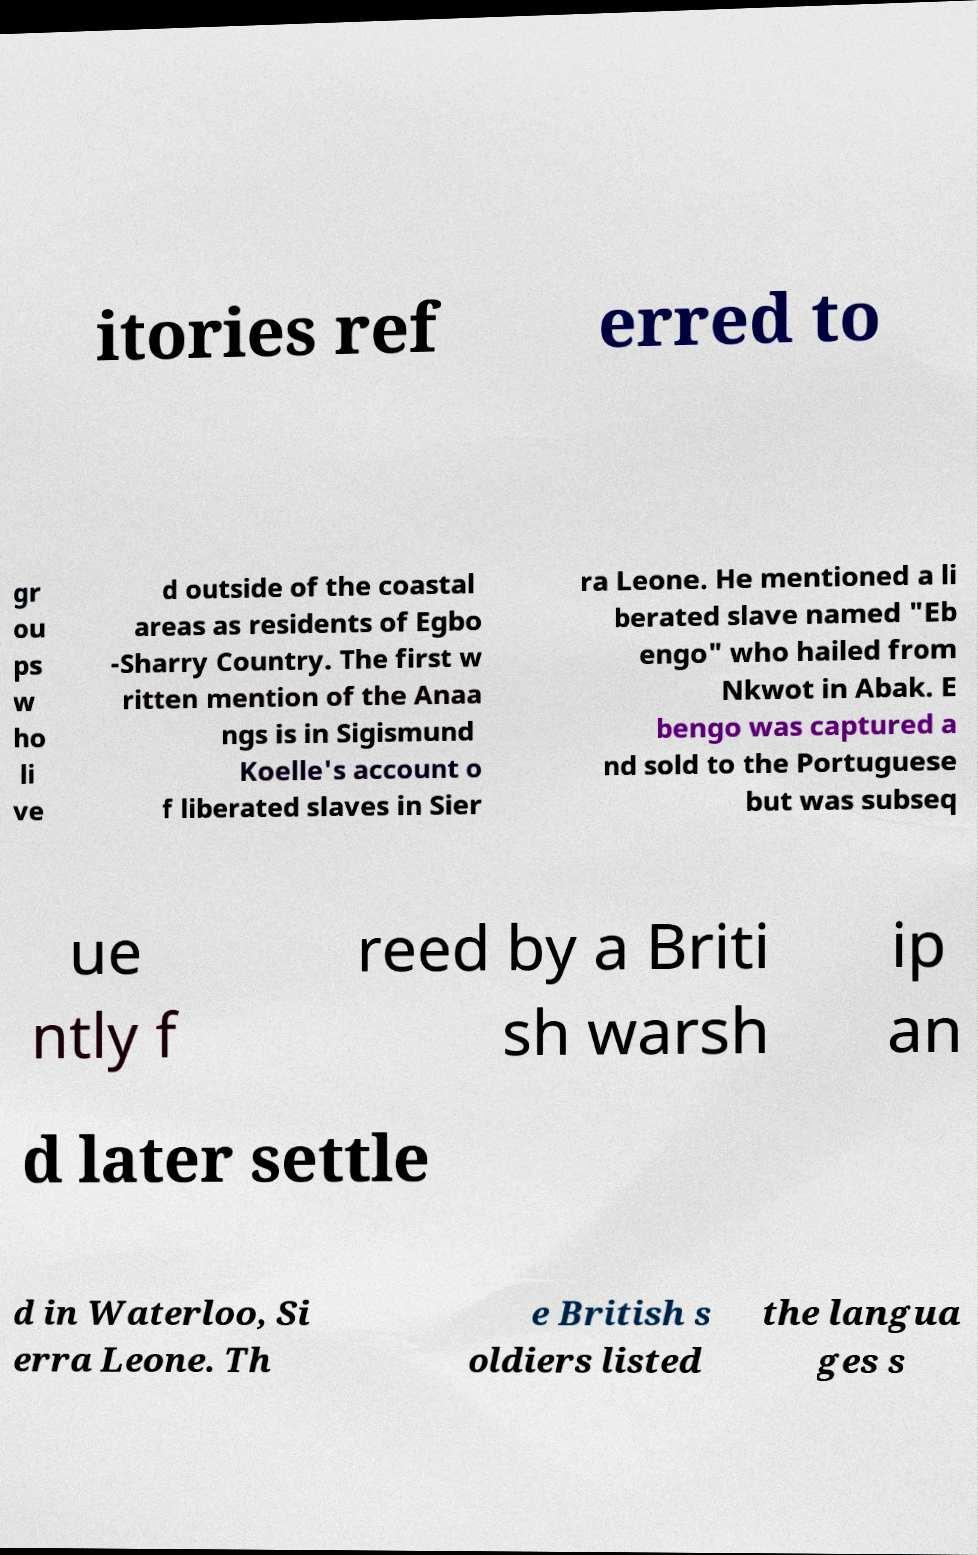There's text embedded in this image that I need extracted. Can you transcribe it verbatim? itories ref erred to gr ou ps w ho li ve d outside of the coastal areas as residents of Egbo -Sharry Country. The first w ritten mention of the Anaa ngs is in Sigismund Koelle's account o f liberated slaves in Sier ra Leone. He mentioned a li berated slave named "Eb engo" who hailed from Nkwot in Abak. E bengo was captured a nd sold to the Portuguese but was subseq ue ntly f reed by a Briti sh warsh ip an d later settle d in Waterloo, Si erra Leone. Th e British s oldiers listed the langua ges s 